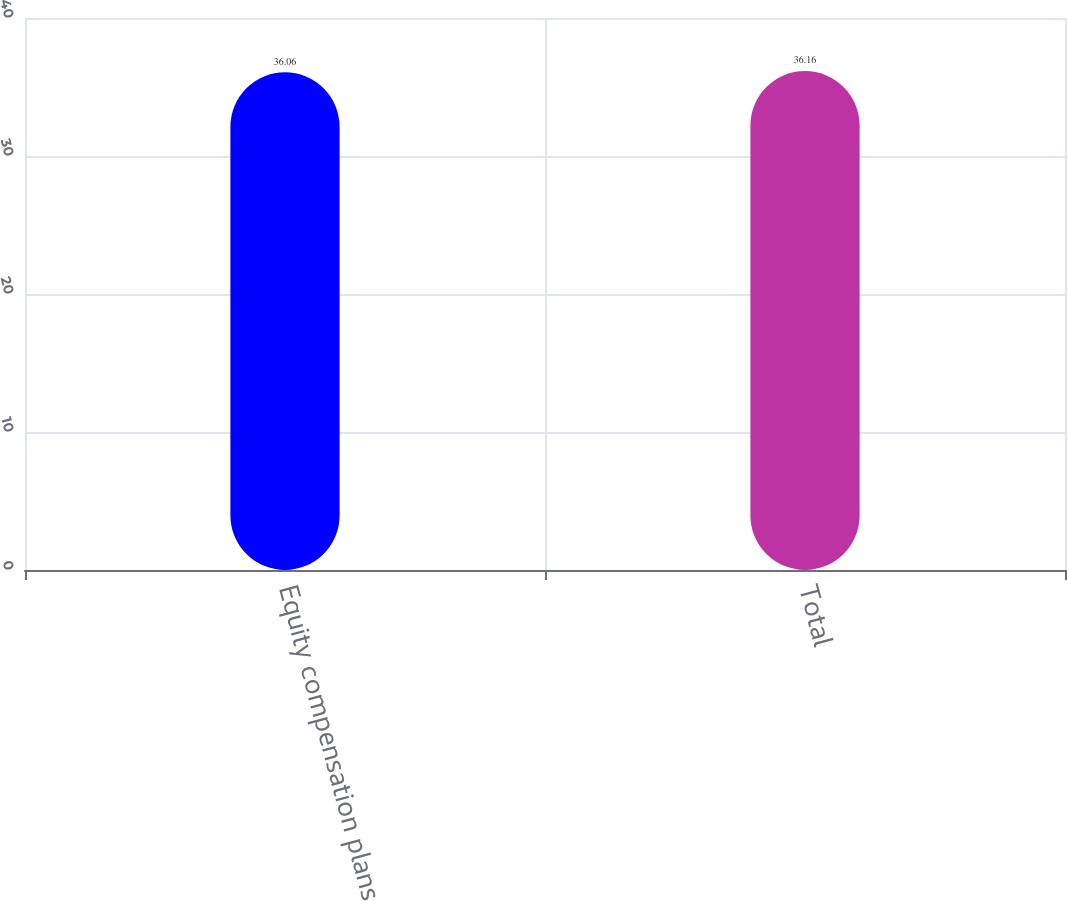Convert chart to OTSL. <chart><loc_0><loc_0><loc_500><loc_500><bar_chart><fcel>Equity compensation plans<fcel>Total<nl><fcel>36.06<fcel>36.16<nl></chart> 